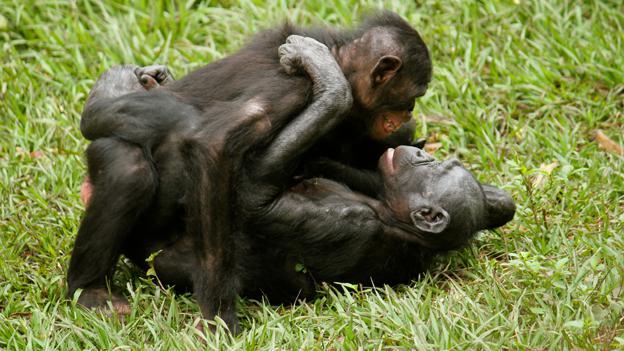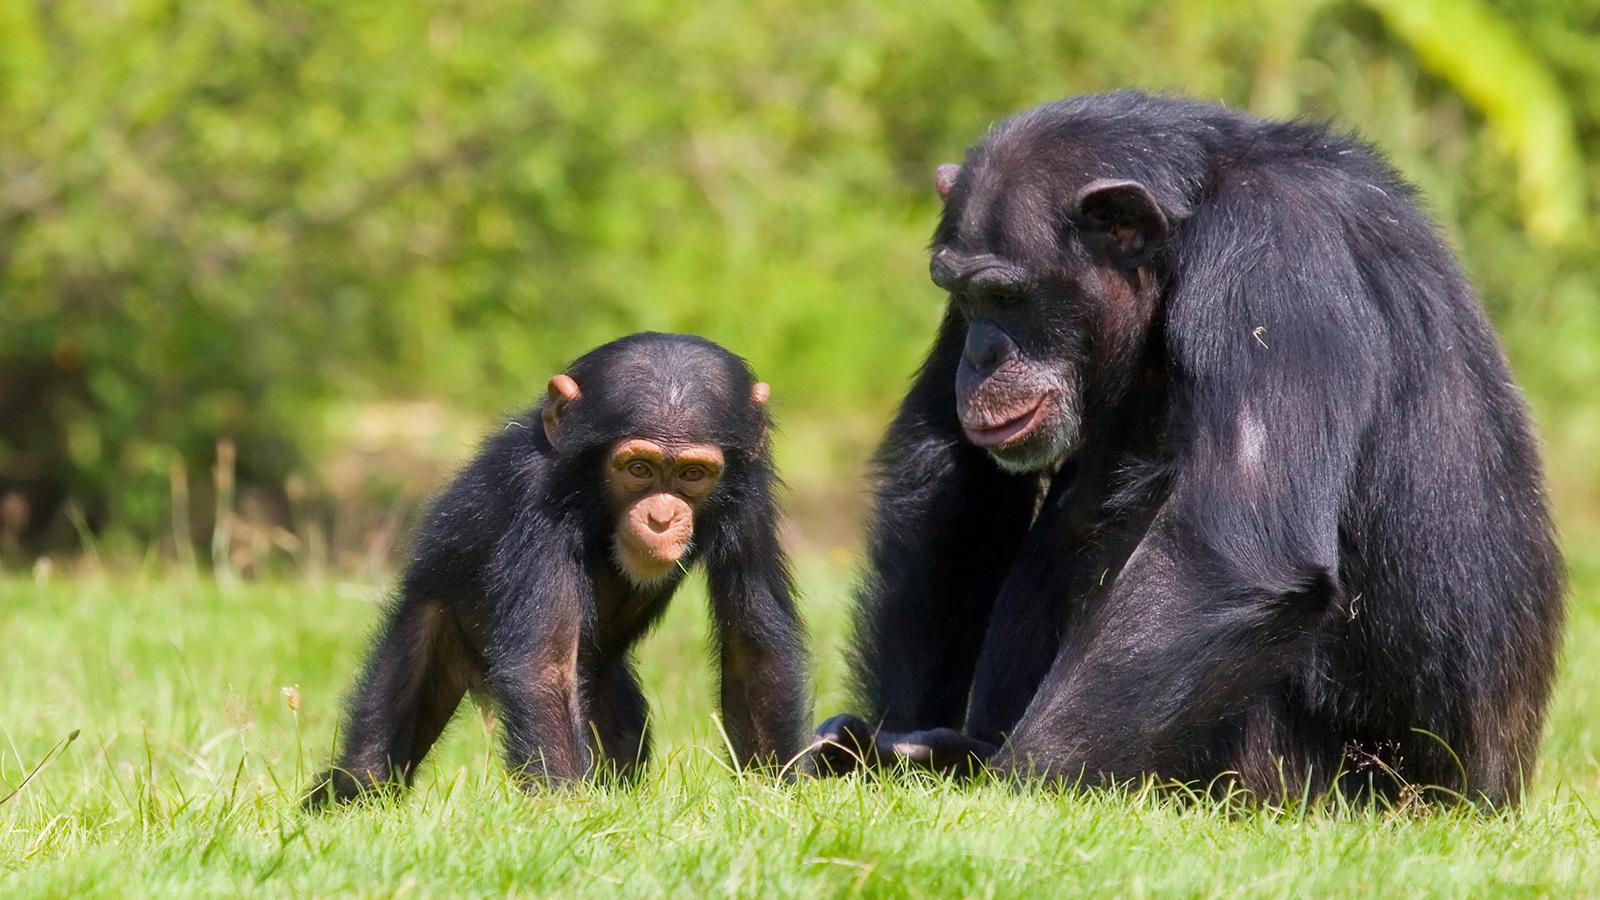The first image is the image on the left, the second image is the image on the right. Analyze the images presented: Is the assertion "A image shows a sitting mother chimp holding a baby chimp." valid? Answer yes or no. No. The first image is the image on the left, the second image is the image on the right. For the images displayed, is the sentence "A mother and a baby ape is pictured on the right image." factually correct? Answer yes or no. Yes. The first image is the image on the left, the second image is the image on the right. Examine the images to the left and right. Is the description "A mother chimpanzee is holding a baby chimpanzee in her arms in one or the images." accurate? Answer yes or no. No. 